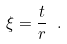Convert formula to latex. <formula><loc_0><loc_0><loc_500><loc_500>\xi = \frac { t } { r } \ .</formula> 